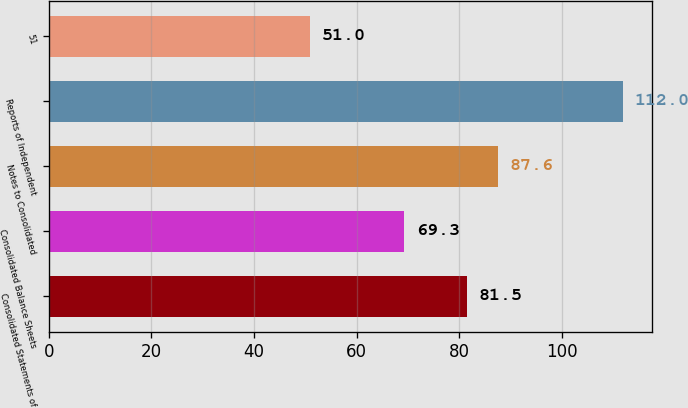Convert chart. <chart><loc_0><loc_0><loc_500><loc_500><bar_chart><fcel>Consolidated Statements of<fcel>Consolidated Balance Sheets<fcel>Notes to Consolidated<fcel>Reports of Independent<fcel>51<nl><fcel>81.5<fcel>69.3<fcel>87.6<fcel>112<fcel>51<nl></chart> 